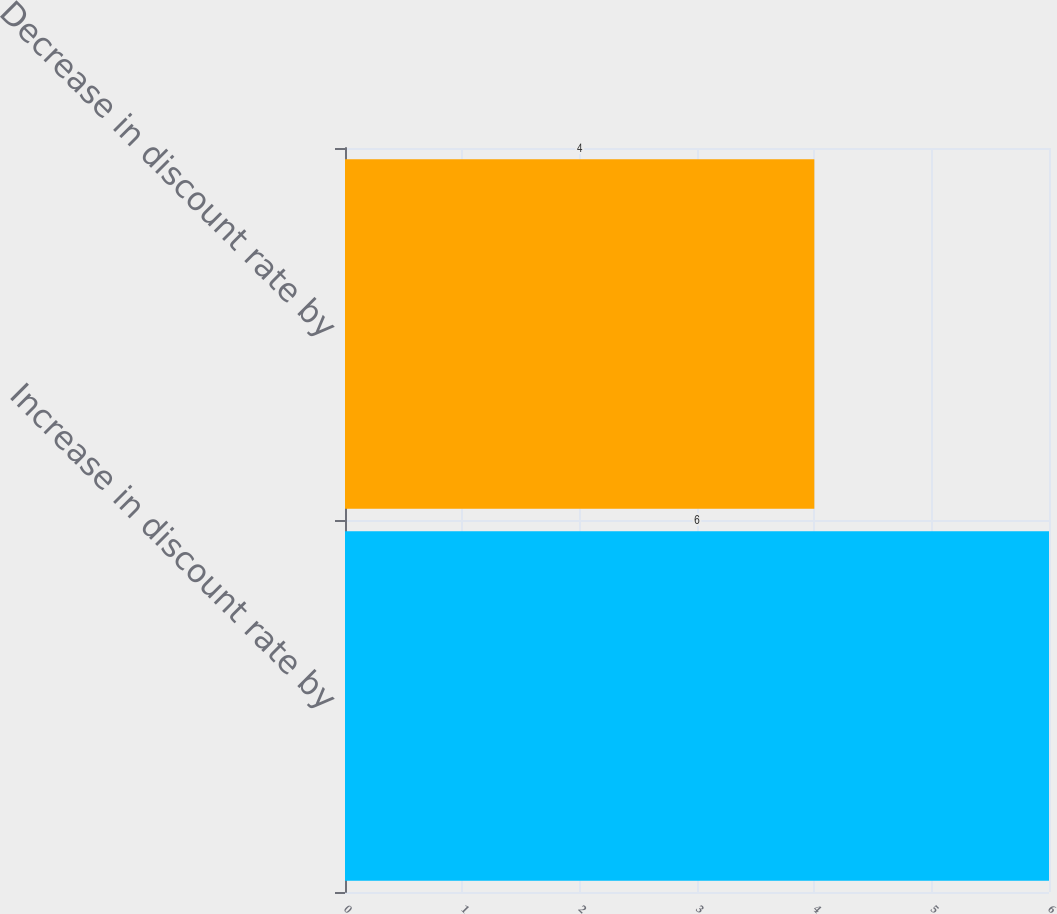Convert chart. <chart><loc_0><loc_0><loc_500><loc_500><bar_chart><fcel>Increase in discount rate by<fcel>Decrease in discount rate by<nl><fcel>6<fcel>4<nl></chart> 